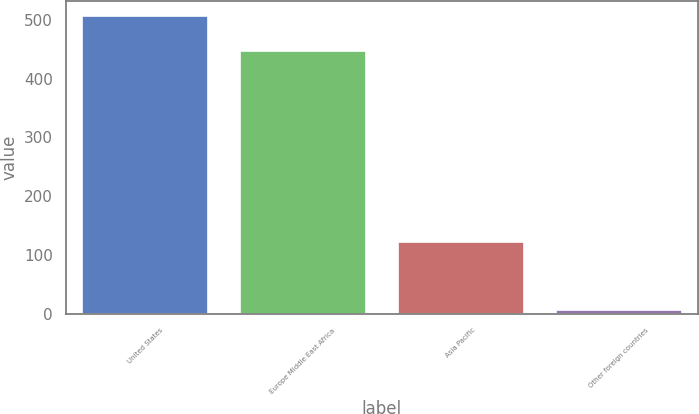Convert chart. <chart><loc_0><loc_0><loc_500><loc_500><bar_chart><fcel>United States<fcel>Europe Middle East Africa<fcel>Asia Pacific<fcel>Other foreign countries<nl><fcel>506<fcel>446<fcel>122<fcel>7<nl></chart> 